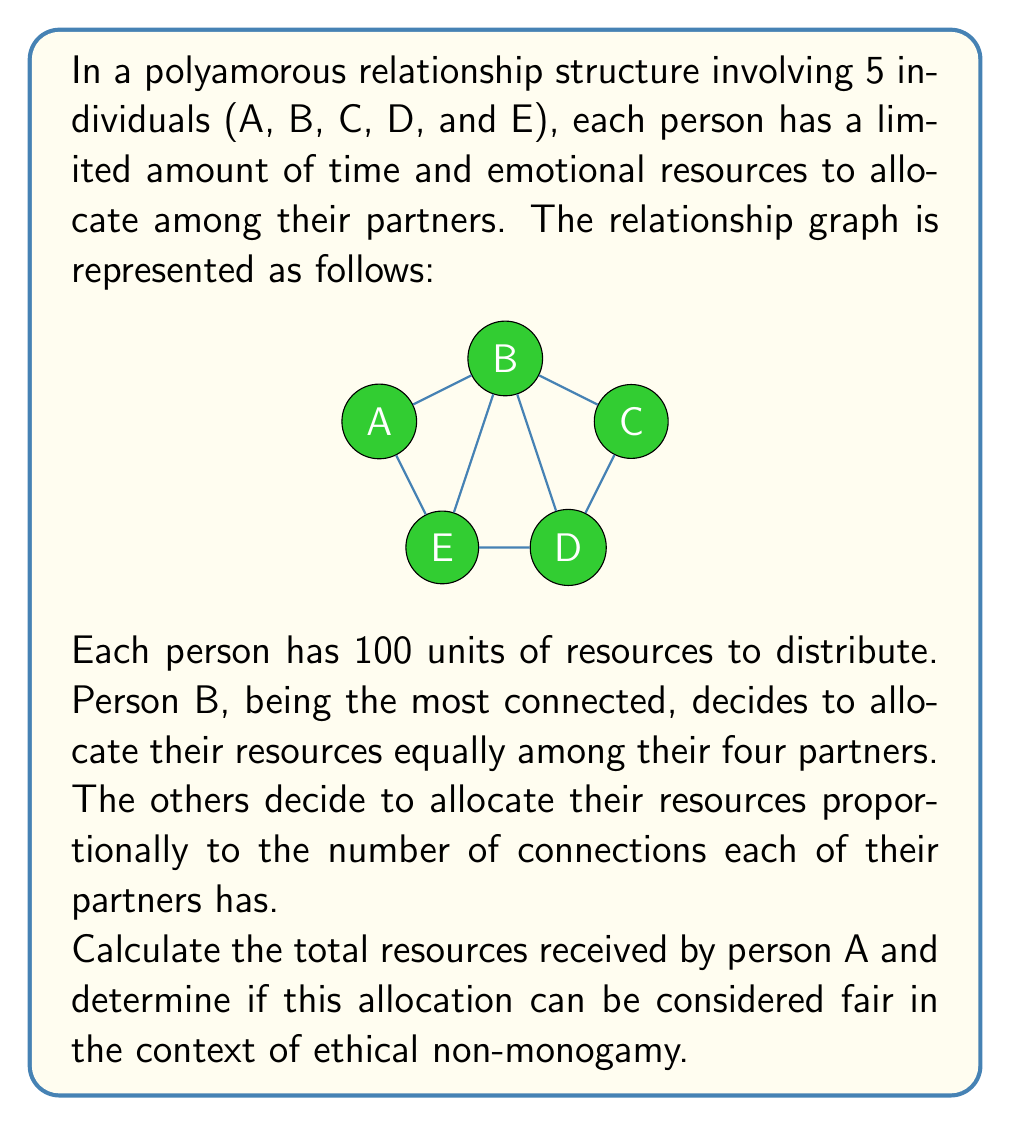Can you answer this question? To solve this problem, we need to follow these steps:

1. Identify the number of connections for each person:
   A: 2 connections (B and E)
   B: 4 connections (A, C, D, and E)
   C: 2 connections (B and D)
   D: 3 connections (B, C, and E)
   E: 3 connections (A, B, and D)

2. Calculate B's resource allocation:
   B has 4 partners and distributes resources equally:
   $$\frac{100}{4} = 25$$ units to each partner (A, C, D, and E)

3. Calculate E's resource allocation to A:
   E has 3 partners (A, B, and D) with 2, 4, and 3 connections respectively.
   Total connections: $2 + 4 + 3 = 9$
   Proportion for A: $\frac{2}{9}$
   Resource allocation: $$100 \times \frac{2}{9} = \frac{200}{9} \approx 22.22$$ units

4. Sum up the resources A receives:
   From B: 25 units
   From E: $\frac{200}{9}$ units
   Total: $$25 + \frac{200}{9} = \frac{425}{9} \approx 47.22$$ units

5. Assess fairness:
   To determine if this allocation is fair, we need to consider several factors:
   a) A has only 2 connections, which is less than average (2.8 connections per person).
   b) A receives less than half of the total possible resources (100 units).
   c) The allocation is based on the number of connections, which may not account for the quality or intensity of relationships.
   d) B's equal distribution might be seen as fair from their perspective, but it doesn't consider the overall network structure.

   In the context of ethical non-monogamy, fairness often involves open communication, consent, and consideration of each individual's needs and boundaries. While the allocation method is systematic, it may not fully address the complexities of human relationships and emotional needs.
Answer: Person A receives a total of $\frac{425}{9} \approx 47.22$ units of resources. This allocation may not be considered entirely fair in the context of ethical non-monogamy, as it doesn't account for the quality of relationships, individual needs, or the overall balance of the relationship structure. A more comprehensive approach involving open communication and consideration of each person's unique situation would be necessary to achieve true fairness in this polyamorous network. 